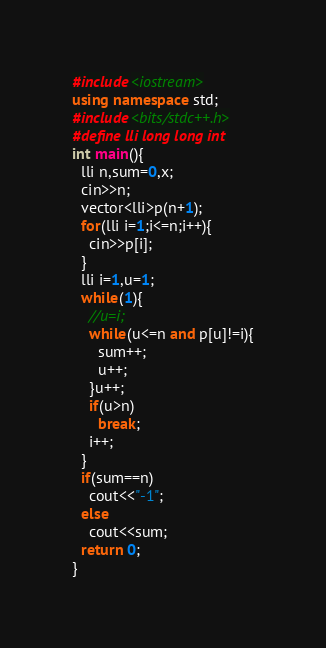Convert code to text. <code><loc_0><loc_0><loc_500><loc_500><_C++_>#include<iostream>
using namespace std;
#include<bits/stdc++.h>
#define lli long long int
int main(){
  lli n,sum=0,x;
  cin>>n;
  vector<lli>p(n+1);
  for(lli i=1;i<=n;i++){
    cin>>p[i];
  }
  lli i=1,u=1;
  while(1){
    //u=i;
    while(u<=n and p[u]!=i){
      sum++;
      u++;
    }u++;
    if(u>n)
      break;
    i++;
  }
  if(sum==n)
    cout<<"-1";
  else
    cout<<sum;
  return 0;
}</code> 